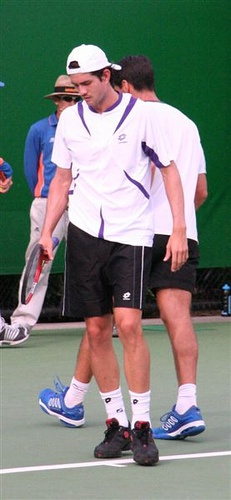Describe the objects in this image and their specific colors. I can see people in darkgreen, lavender, black, lightpink, and brown tones, people in darkgreen, lavender, black, brown, and salmon tones, people in darkgreen, blue, pink, and darkgray tones, tennis racket in darkgreen, gray, darkgray, brown, and black tones, and people in darkgreen, brown, blue, salmon, and maroon tones in this image. 